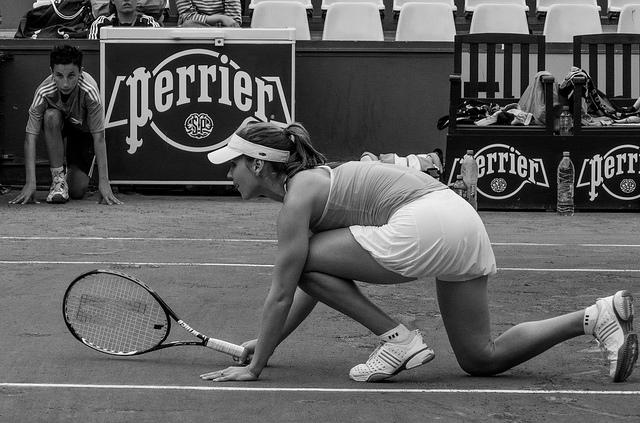Is the woman wearing tennis shoes?
Concise answer only. Yes. Is the woman playing basketball?
Write a very short answer. No. Where are the chairs?
Write a very short answer. Back. 